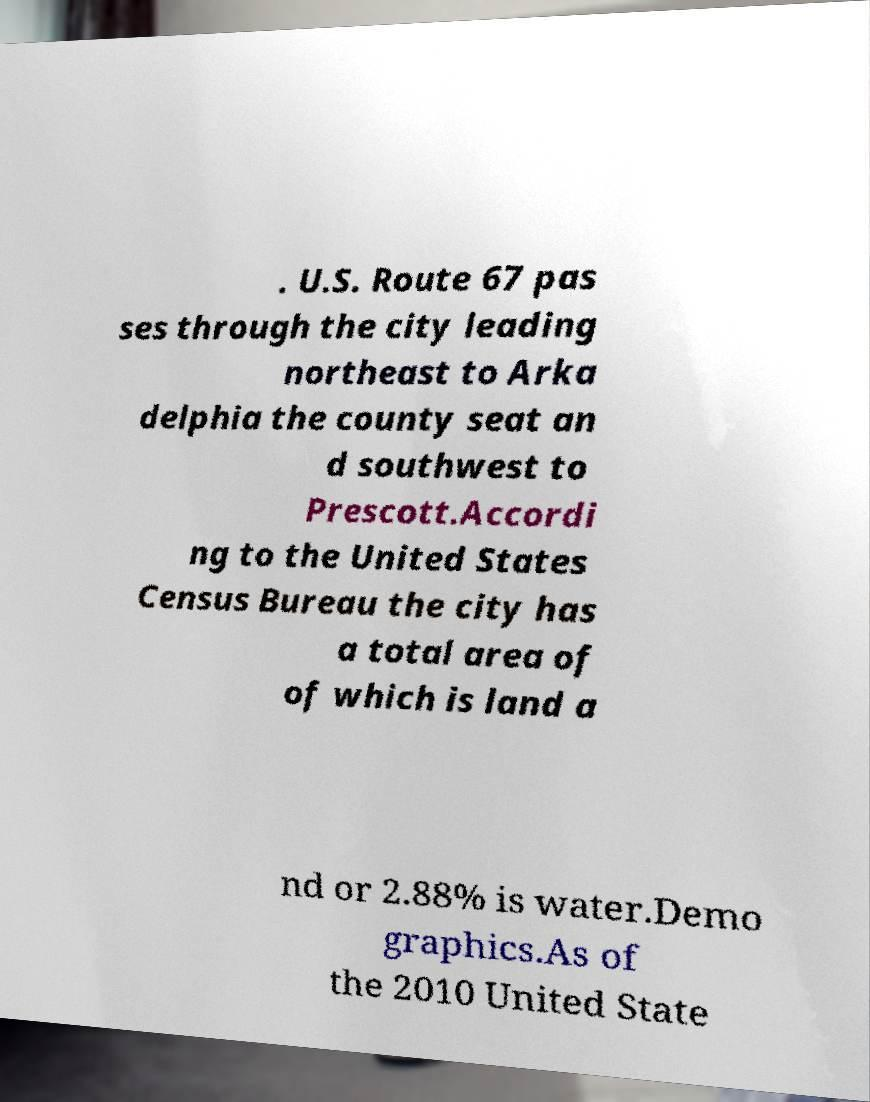What messages or text are displayed in this image? I need them in a readable, typed format. . U.S. Route 67 pas ses through the city leading northeast to Arka delphia the county seat an d southwest to Prescott.Accordi ng to the United States Census Bureau the city has a total area of of which is land a nd or 2.88% is water.Demo graphics.As of the 2010 United State 